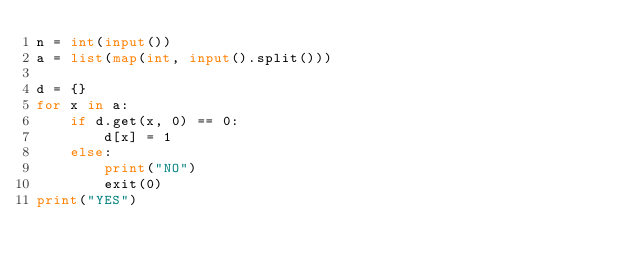<code> <loc_0><loc_0><loc_500><loc_500><_Python_>n = int(input())
a = list(map(int, input().split()))

d = {}
for x in a:
    if d.get(x, 0) == 0:
        d[x] = 1
    else:
        print("NO")
        exit(0)
print("YES")

</code> 